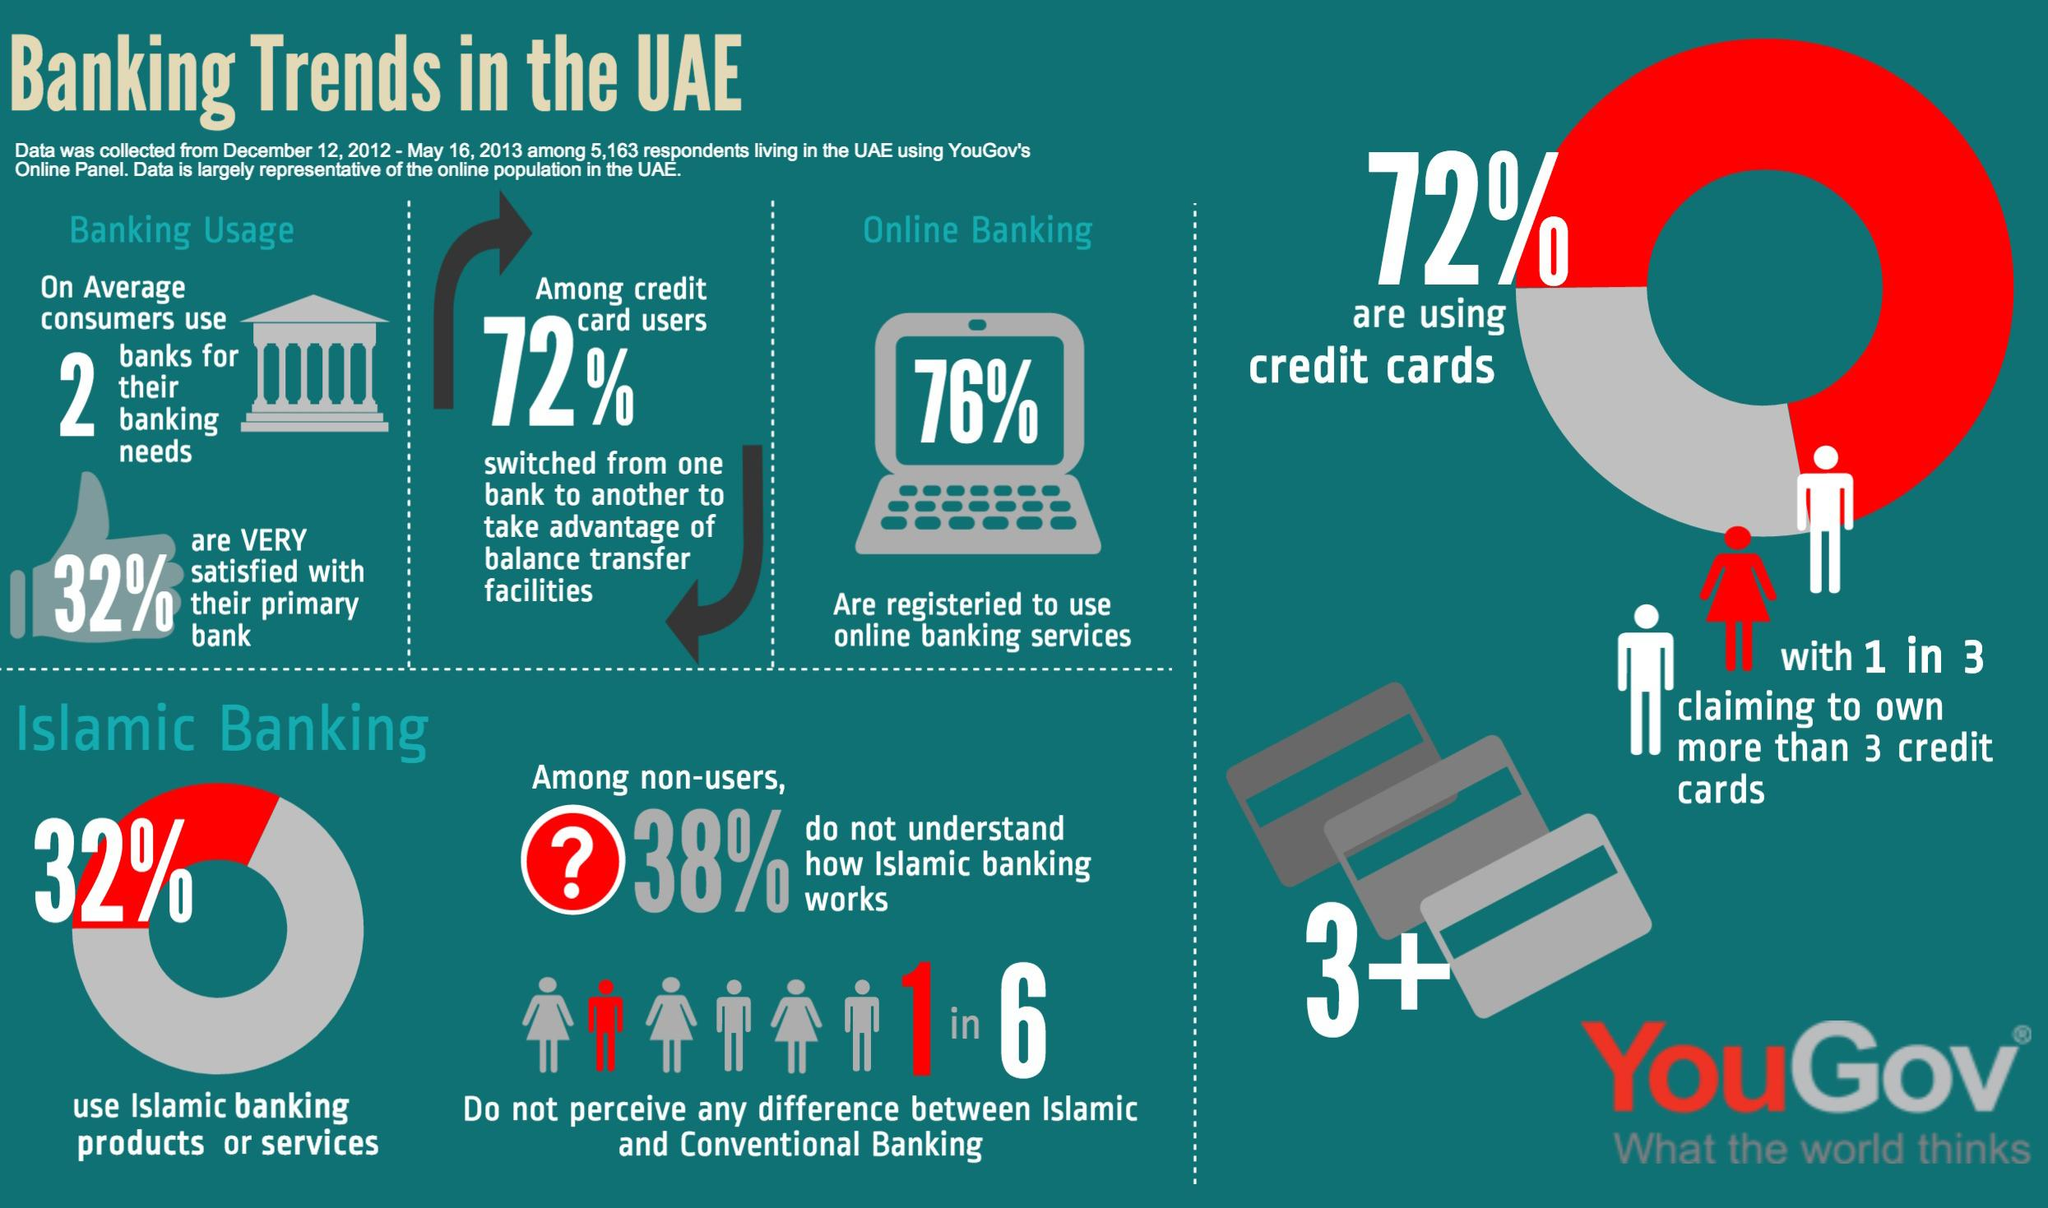Identify some key points in this picture. According to the survey, 68% of respondents living in the UAE do not use Islamic banking products or services. According to the survey, approximately 28% of respondents living in the UAE have not used credit cards. According to the survey, 76% of respondents living in the UAE use online banking services. 